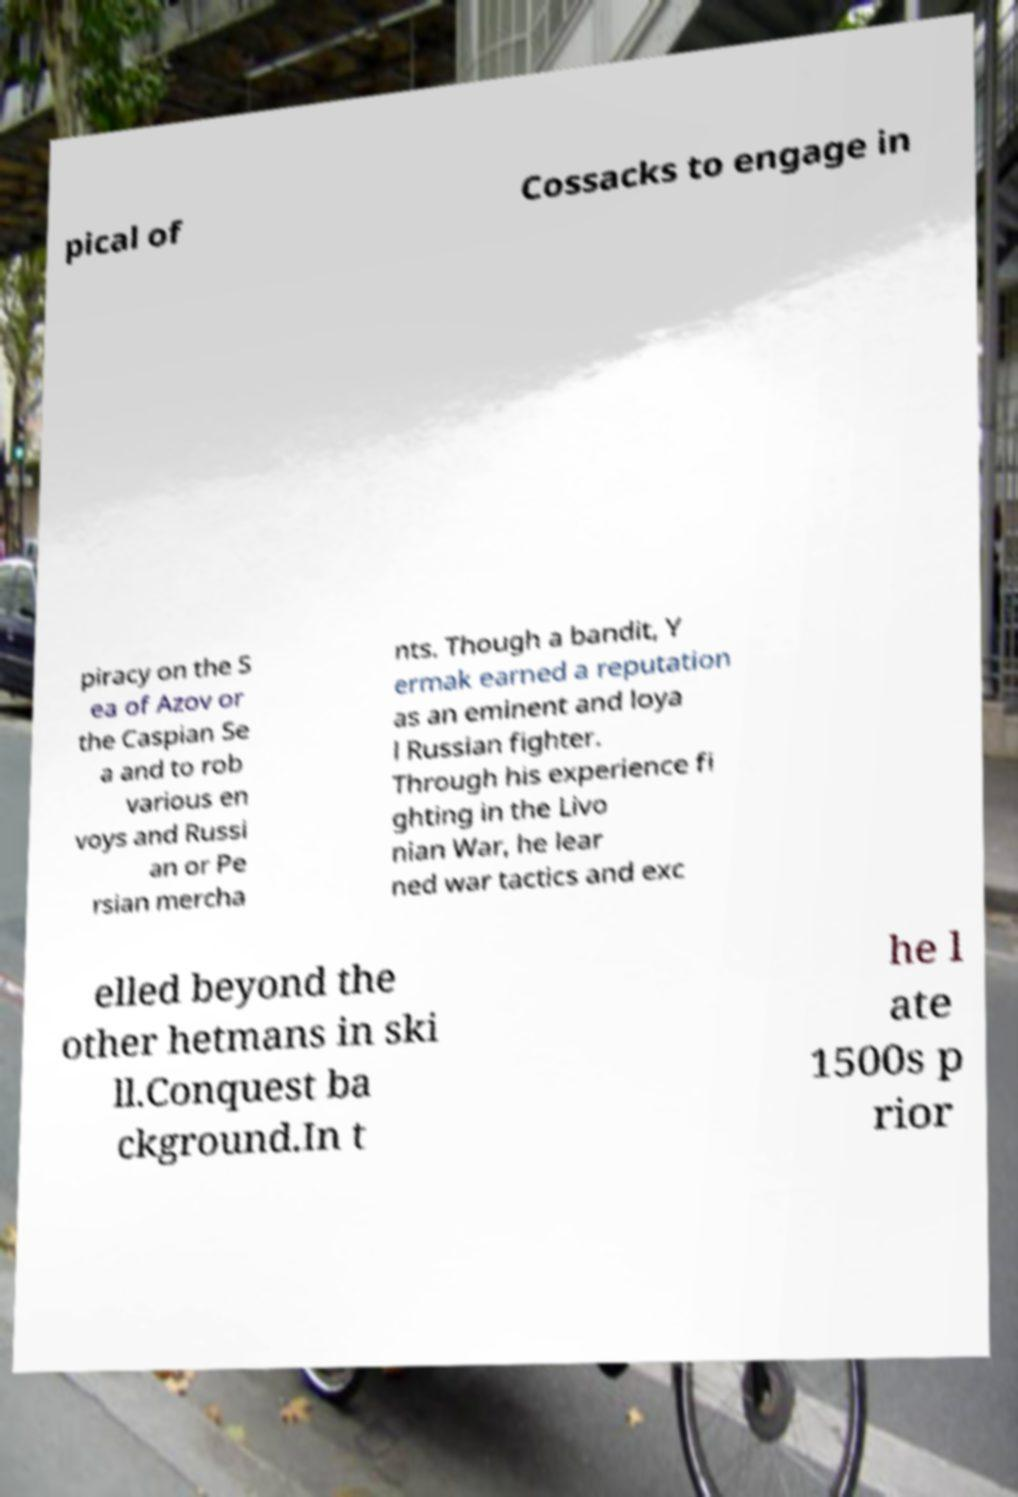For documentation purposes, I need the text within this image transcribed. Could you provide that? pical of Cossacks to engage in piracy on the S ea of Azov or the Caspian Se a and to rob various en voys and Russi an or Pe rsian mercha nts. Though a bandit, Y ermak earned a reputation as an eminent and loya l Russian fighter. Through his experience fi ghting in the Livo nian War, he lear ned war tactics and exc elled beyond the other hetmans in ski ll.Conquest ba ckground.In t he l ate 1500s p rior 